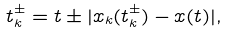<formula> <loc_0><loc_0><loc_500><loc_500>t _ { k } ^ { \pm } = t \pm | x _ { k } ( t _ { k } ^ { \pm } ) - x ( t ) | ,</formula> 